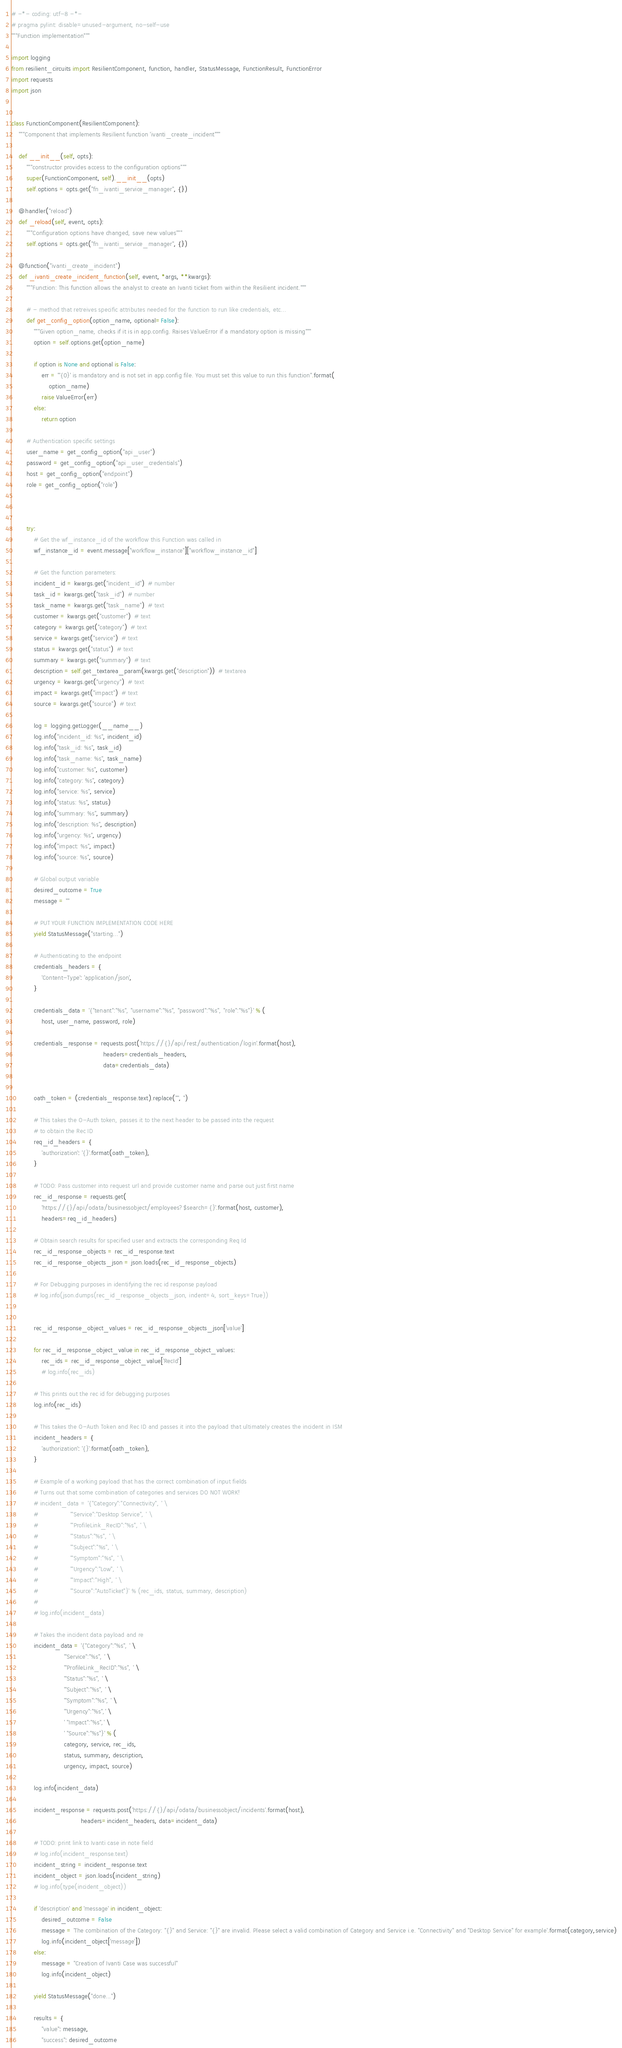<code> <loc_0><loc_0><loc_500><loc_500><_Python_># -*- coding: utf-8 -*-
# pragma pylint: disable=unused-argument, no-self-use
"""Function implementation"""

import logging
from resilient_circuits import ResilientComponent, function, handler, StatusMessage, FunctionResult, FunctionError
import requests
import json


class FunctionComponent(ResilientComponent):
    """Component that implements Resilient function 'ivanti_create_incident"""

    def __init__(self, opts):
        """constructor provides access to the configuration options"""
        super(FunctionComponent, self).__init__(opts)
        self.options = opts.get("fn_ivanti_service_manager", {})

    @handler("reload")
    def _reload(self, event, opts):
        """Configuration options have changed, save new values"""
        self.options = opts.get("fn_ivanti_service_manager", {})

    @function("ivanti_create_incident")
    def _ivanti_create_incident_function(self, event, *args, **kwargs):
        """Function: This function allows the analyst to create an Ivanti ticket from within the Resilient incident."""

        # - method that retreives specific attributes needed for the function to run like credentials, etc...
        def get_config_option(option_name, optional=False):
            """Given option_name, checks if it is in app.config. Raises ValueError if a mandatory option is missing"""
            option = self.options.get(option_name)

            if option is None and optional is False:
                err = "'{0}' is mandatory and is not set in app.config file. You must set this value to run this function".format(
                    option_name)
                raise ValueError(err)
            else:
                return option

        # Authentication specific settings
        user_name = get_config_option("api_user")
        password = get_config_option("api_user_credentials")
        host = get_config_option("endpoint")
        role = get_config_option("role")



        try:
            # Get the wf_instance_id of the workflow this Function was called in
            wf_instance_id = event.message["workflow_instance"]["workflow_instance_id"]

            # Get the function parameters:
            incident_id = kwargs.get("incident_id")  # number
            task_id = kwargs.get("task_id")  # number
            task_name = kwargs.get("task_name")  # text
            customer = kwargs.get("customer")  # text
            category = kwargs.get("category")  # text
            service = kwargs.get("service")  # text
            status = kwargs.get("status")  # text
            summary = kwargs.get("summary")  # text
            description = self.get_textarea_param(kwargs.get("description"))  # textarea
            urgency = kwargs.get("urgency")  # text
            impact = kwargs.get("impact")  # text
            source = kwargs.get("source")  # text

            log = logging.getLogger(__name__)
            log.info("incident_id: %s", incident_id)
            log.info("task_id: %s", task_id)
            log.info("task_name: %s", task_name)
            log.info("customer: %s", customer)
            log.info("category: %s", category)
            log.info("service: %s", service)
            log.info("status: %s", status)
            log.info("summary: %s", summary)
            log.info("description: %s", description)
            log.info("urgency: %s", urgency)
            log.info("impact: %s", impact)
            log.info("source: %s", source)

            # Global output variable
            desired_outcome = True
            message = ""

            # PUT YOUR FUNCTION IMPLEMENTATION CODE HERE
            yield StatusMessage("starting...")

            # Authenticating to the endpoint
            credentials_headers = {
                'Content-Type': 'application/json',
            }

            credentials_data = '{"tenant":"%s", "username":"%s", "password":"%s", "role":"%s"}' % (
                host, user_name, password, role)

            credentials_response = requests.post('https://{}/api/rest/authentication/login'.format(host),
                                                 headers=credentials_headers,
                                                 data=credentials_data)


            oath_token = (credentials_response.text).replace('"', '')

            # This takes the O-Auth token, passes it to the next header to be passed into the request
            # to obtain the Rec ID
            req_id_headers = {
                'authorization': '{}'.format(oath_token),
            }

            # TODO: Pass customer into request url and provide customer name and parse out just first name
            rec_id_response = requests.get(
                'https://{}/api/odata/businessobject/employees?$search={}'.format(host, customer),
                headers=req_id_headers)

            # Obtain search results for specified user and extracts the corresponding Req Id
            rec_id_response_objects = rec_id_response.text
            rec_id_response_objects_json = json.loads(rec_id_response_objects)

            # For Debugging purposes in identifying the rec id response payload
            # log.info(json.dumps(rec_id_response_objects_json, indent=4, sort_keys=True))


            rec_id_response_object_values = rec_id_response_objects_json['value']

            for rec_id_response_object_value in rec_id_response_object_values:
                rec_ids = rec_id_response_object_value['RecId']
                # log.info(rec_ids)

            # This prints out the rec id for debugging purposes
            log.info(rec_ids)

            # This takes the O-Auth Token and Rec ID and passes it into the payload that ultimately creates the incident in ISM
            incident_headers = {
                'authorization': '{}'.format(oath_token),
            }

            # Example of a working payload that has the correct combination of input fields
            # Turns out that some combination of categories and services DO NOT WORK!
            # incident_data = '{"Category":"Connectivity", ' \
            #                 '"Service":"Desktop Service", ' \
            #                 '"ProfileLink_RecID":"%s", ' \
            #                 '"Status":"%s", ' \
            #                 '"Subject":"%s", ' \
            #                 '"Symptom":"%s", ' \
            #                 '"Urgency":"Low", ' \
            #                 '"Impact":"High", ' \
            #                 '"Source":"AutoTicket"}' % (rec_ids, status, summary, description)
            #
            # log.info(incident_data)

            # Takes the incident data payload and re
            incident_data = '{"Category":"%s", ' \
                            '"Service":"%s", ' \
                            '"ProfileLink_RecID":"%s", ' \
                            '"Status":"%s", ' \
                            '"Subject":"%s", ' \
                            '"Symptom":"%s", ' \
                            '"Urgency":"%s",' \
                            ' "Impact":"%s",' \
                            ' "Source":"%s"}' % (
                            category, service, rec_ids,
                            status, summary, description,
                            urgency, impact, source)

            log.info(incident_data)

            incident_response = requests.post('https://{}/api/odata/businessobject/incidents'.format(host),
                                     headers=incident_headers, data=incident_data)

            # TODO: print link to Ivanti case in note field
            # log.info(incident_response.text)
            incident_string = incident_response.text
            incident_object = json.loads(incident_string)
            # log.info(type(incident_object))

            if 'description' and 'message' in incident_object:
                desired_outcome = False
                message = 'The combination of the Category: "{}" and Service: "{}" are invalid. Please select a valid combination of Category and Service i.e. "Connectivity" and "Desktop Service" for example'.format(category,service)
                log.info(incident_object['message'])
            else:
                message = "Creation of Ivanti Case was successful"
                log.info(incident_object)

            yield StatusMessage("done...")

            results = {
                "value": message,
                "success": desired_outcome</code> 